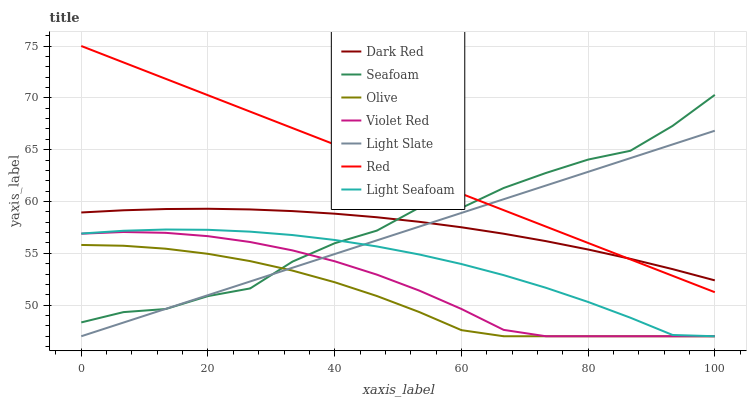Does Olive have the minimum area under the curve?
Answer yes or no. Yes. Does Red have the maximum area under the curve?
Answer yes or no. Yes. Does Light Slate have the minimum area under the curve?
Answer yes or no. No. Does Light Slate have the maximum area under the curve?
Answer yes or no. No. Is Light Slate the smoothest?
Answer yes or no. Yes. Is Seafoam the roughest?
Answer yes or no. Yes. Is Dark Red the smoothest?
Answer yes or no. No. Is Dark Red the roughest?
Answer yes or no. No. Does Violet Red have the lowest value?
Answer yes or no. Yes. Does Dark Red have the lowest value?
Answer yes or no. No. Does Red have the highest value?
Answer yes or no. Yes. Does Light Slate have the highest value?
Answer yes or no. No. Is Violet Red less than Dark Red?
Answer yes or no. Yes. Is Red greater than Violet Red?
Answer yes or no. Yes. Does Light Seafoam intersect Violet Red?
Answer yes or no. Yes. Is Light Seafoam less than Violet Red?
Answer yes or no. No. Is Light Seafoam greater than Violet Red?
Answer yes or no. No. Does Violet Red intersect Dark Red?
Answer yes or no. No. 